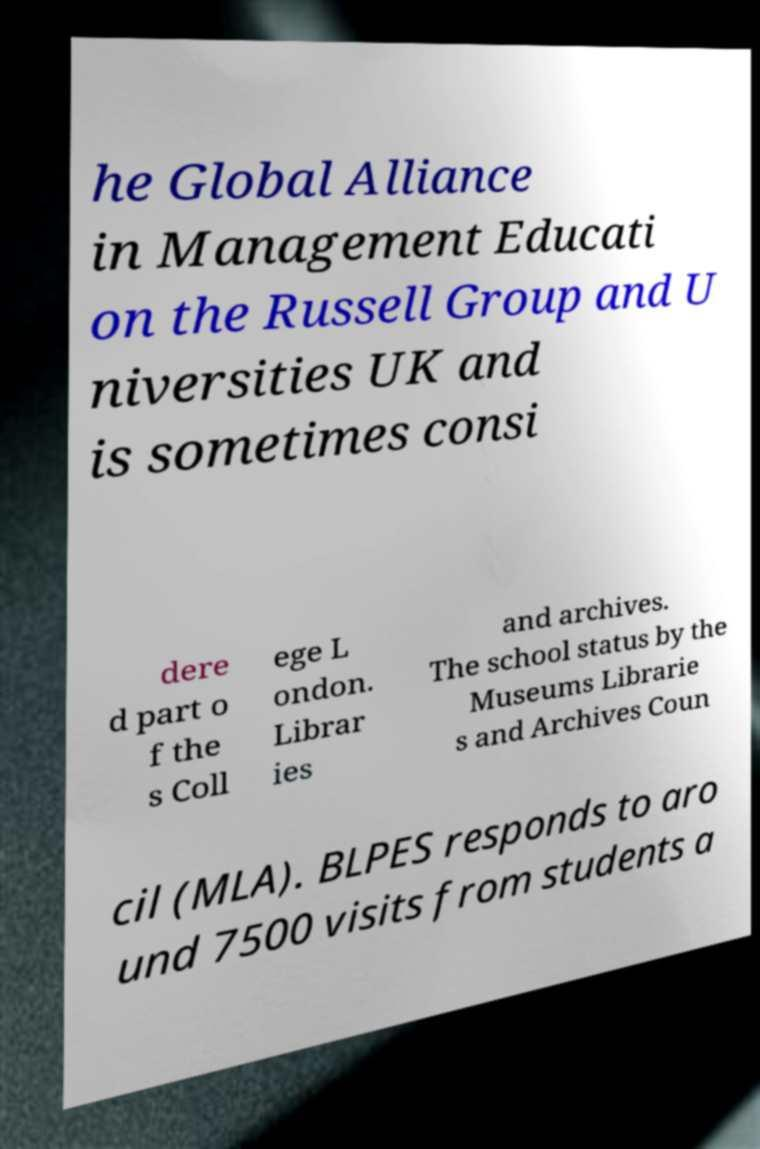Can you read and provide the text displayed in the image?This photo seems to have some interesting text. Can you extract and type it out for me? he Global Alliance in Management Educati on the Russell Group and U niversities UK and is sometimes consi dere d part o f the s Coll ege L ondon. Librar ies and archives. The school status by the Museums Librarie s and Archives Coun cil (MLA). BLPES responds to aro und 7500 visits from students a 